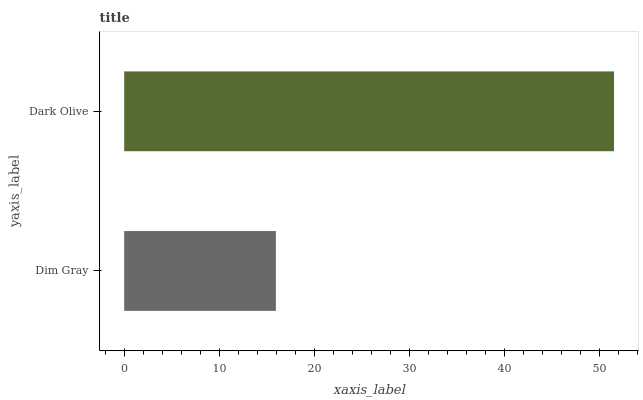Is Dim Gray the minimum?
Answer yes or no. Yes. Is Dark Olive the maximum?
Answer yes or no. Yes. Is Dark Olive the minimum?
Answer yes or no. No. Is Dark Olive greater than Dim Gray?
Answer yes or no. Yes. Is Dim Gray less than Dark Olive?
Answer yes or no. Yes. Is Dim Gray greater than Dark Olive?
Answer yes or no. No. Is Dark Olive less than Dim Gray?
Answer yes or no. No. Is Dark Olive the high median?
Answer yes or no. Yes. Is Dim Gray the low median?
Answer yes or no. Yes. Is Dim Gray the high median?
Answer yes or no. No. Is Dark Olive the low median?
Answer yes or no. No. 